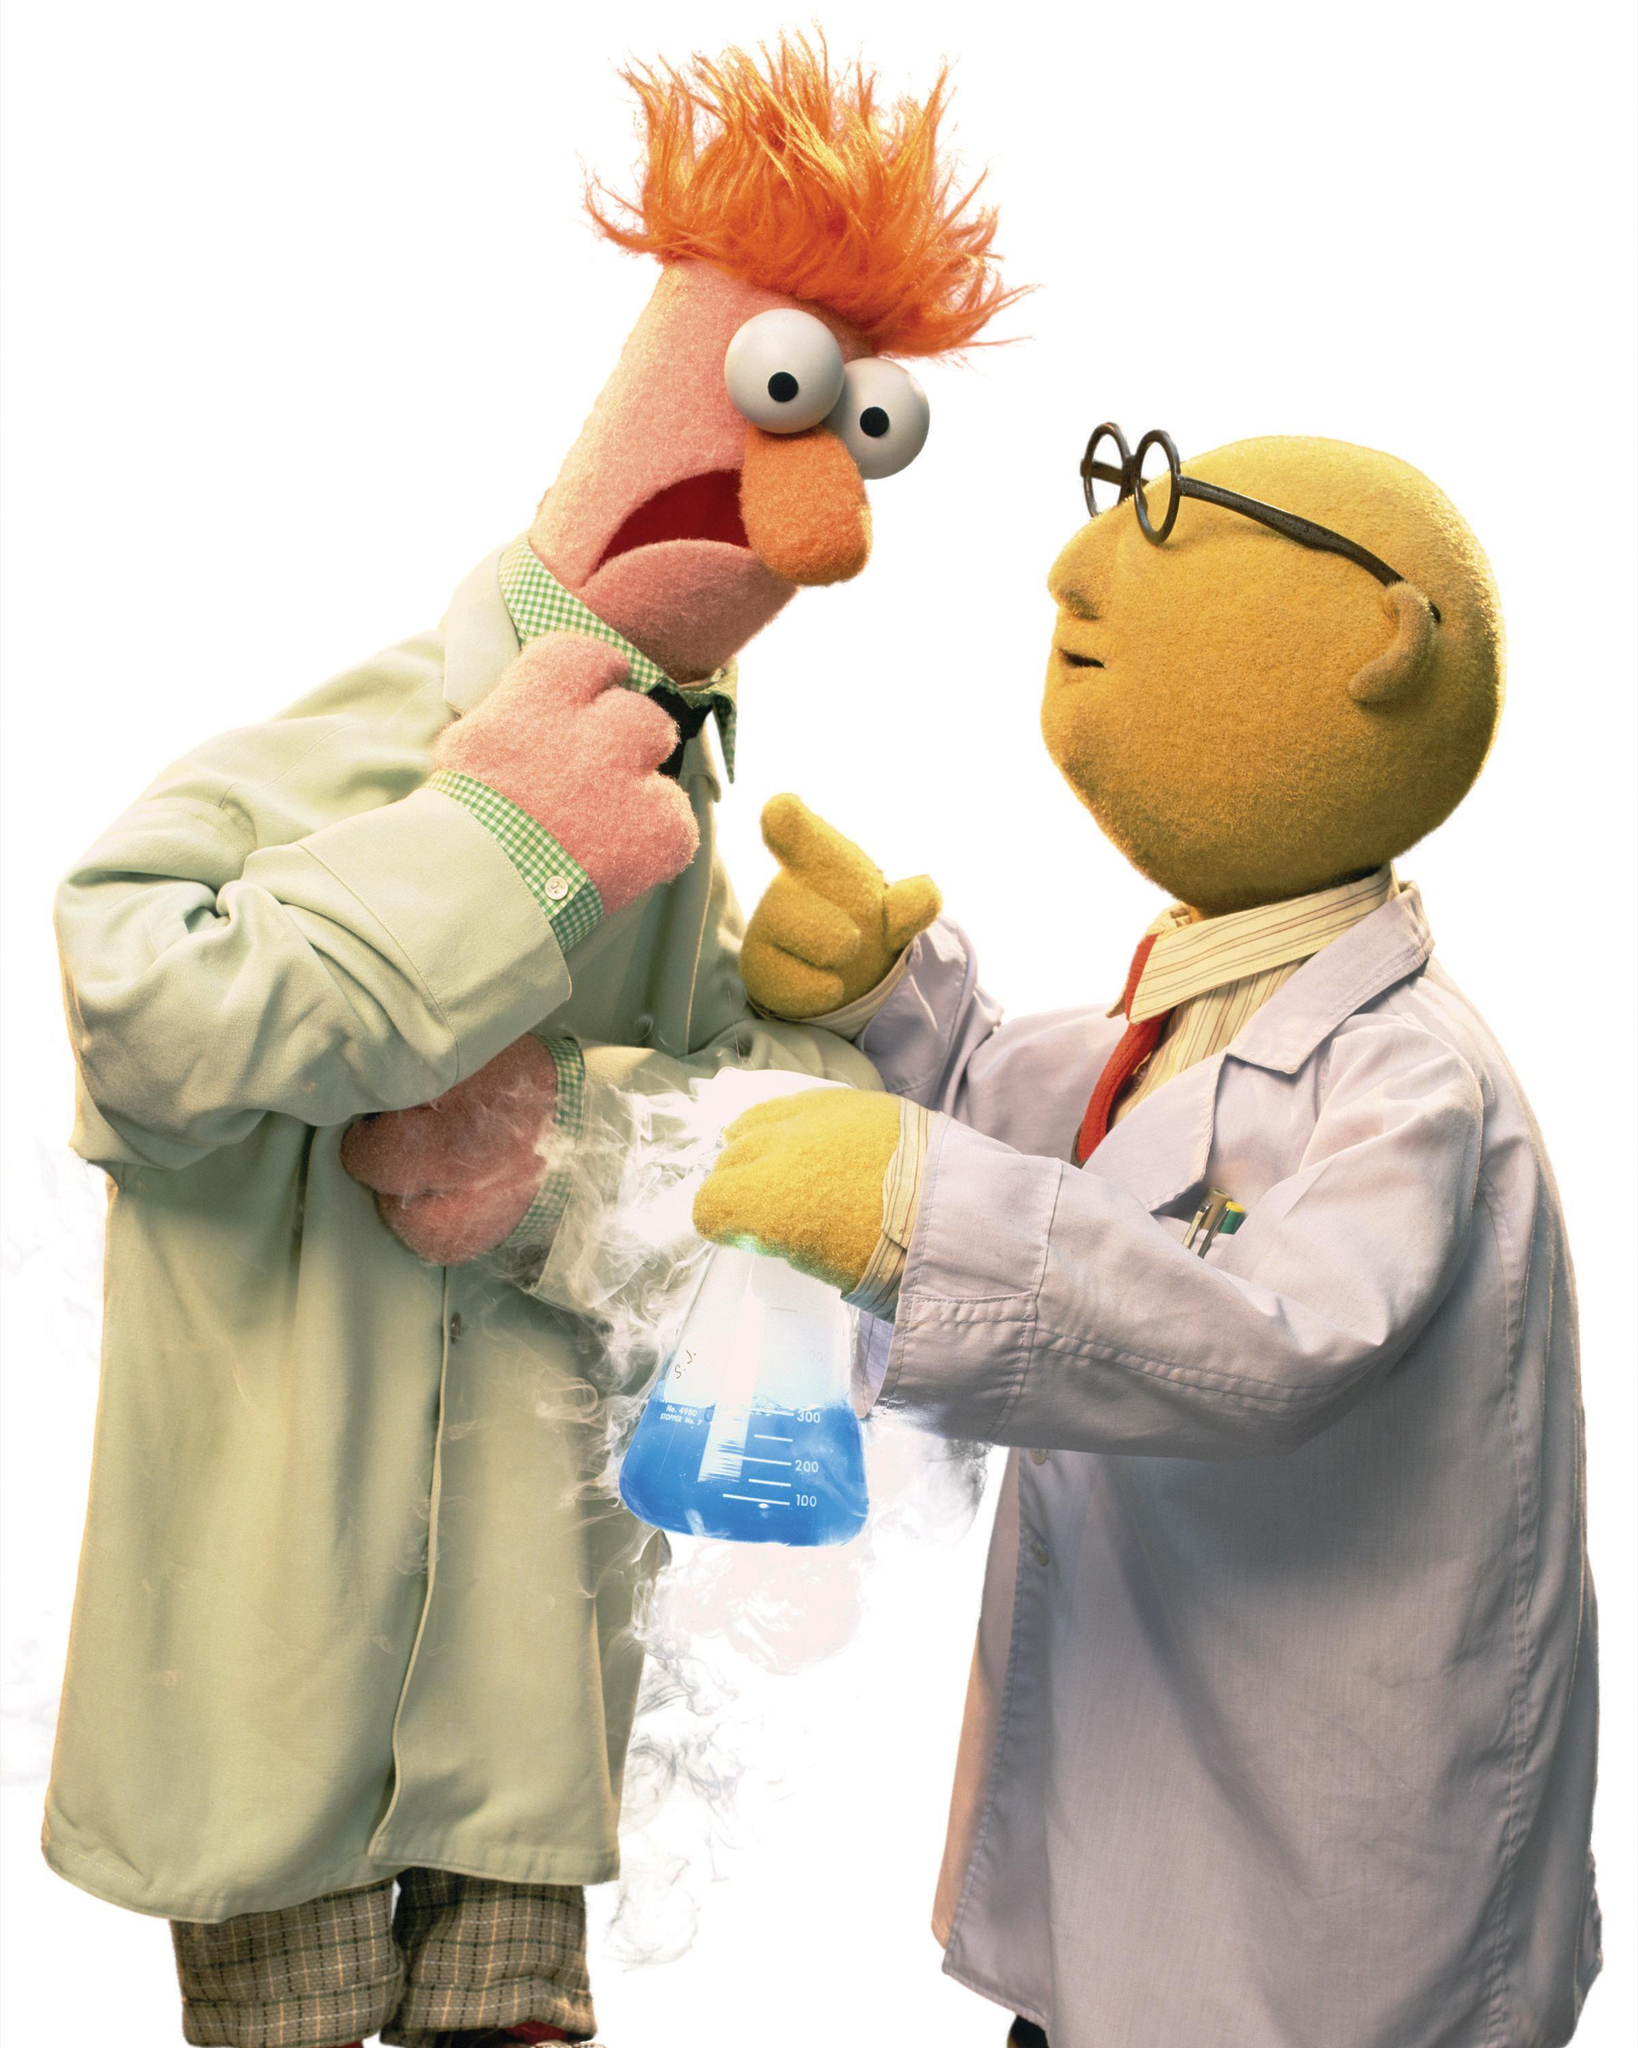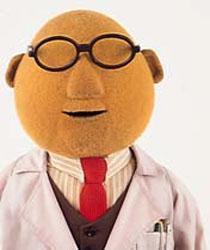The first image is the image on the left, the second image is the image on the right. Considering the images on both sides, is "Each image has the same two muppets without any other muppets." valid? Answer yes or no. No. 